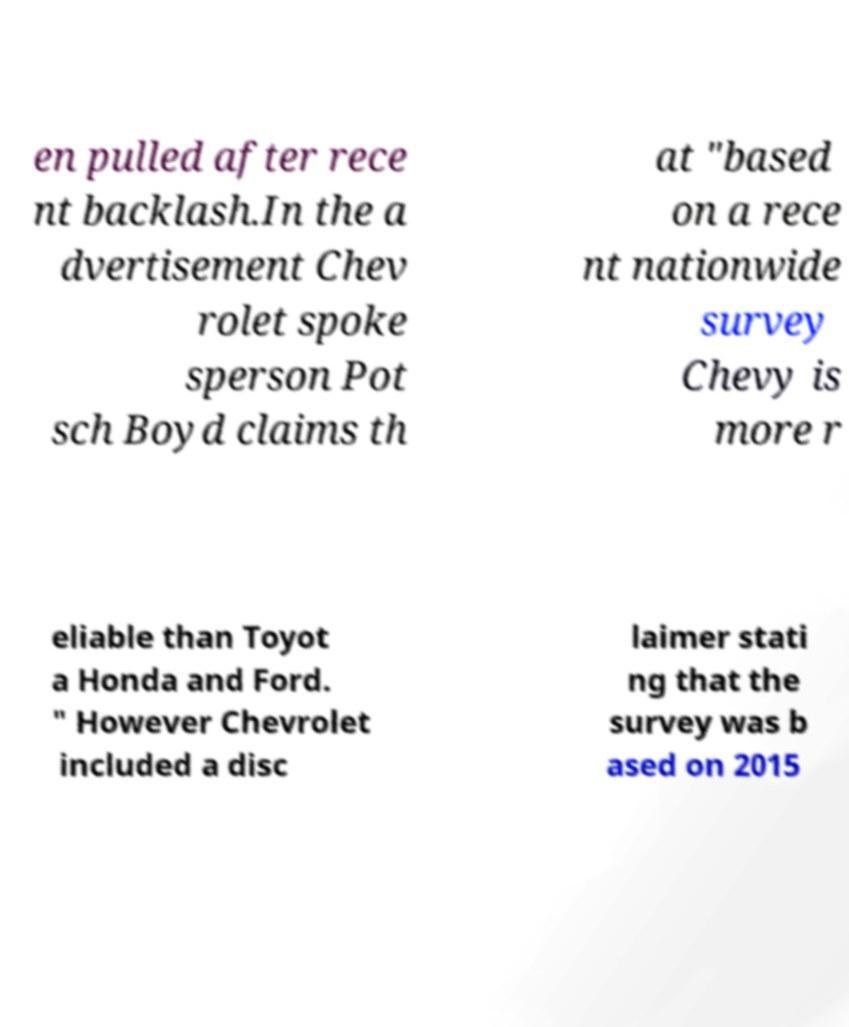I need the written content from this picture converted into text. Can you do that? en pulled after rece nt backlash.In the a dvertisement Chev rolet spoke sperson Pot sch Boyd claims th at "based on a rece nt nationwide survey Chevy is more r eliable than Toyot a Honda and Ford. " However Chevrolet included a disc laimer stati ng that the survey was b ased on 2015 